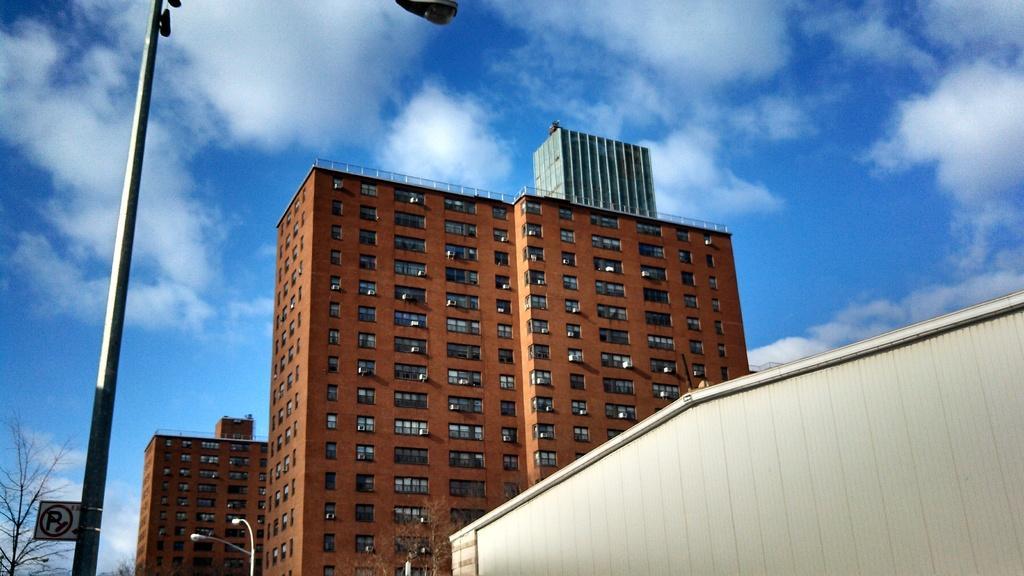Could you give a brief overview of what you see in this image? In this image I can see few buildings, windows, few light poles, dry trees and the sky. I can see the sign board is attached to the pole. 